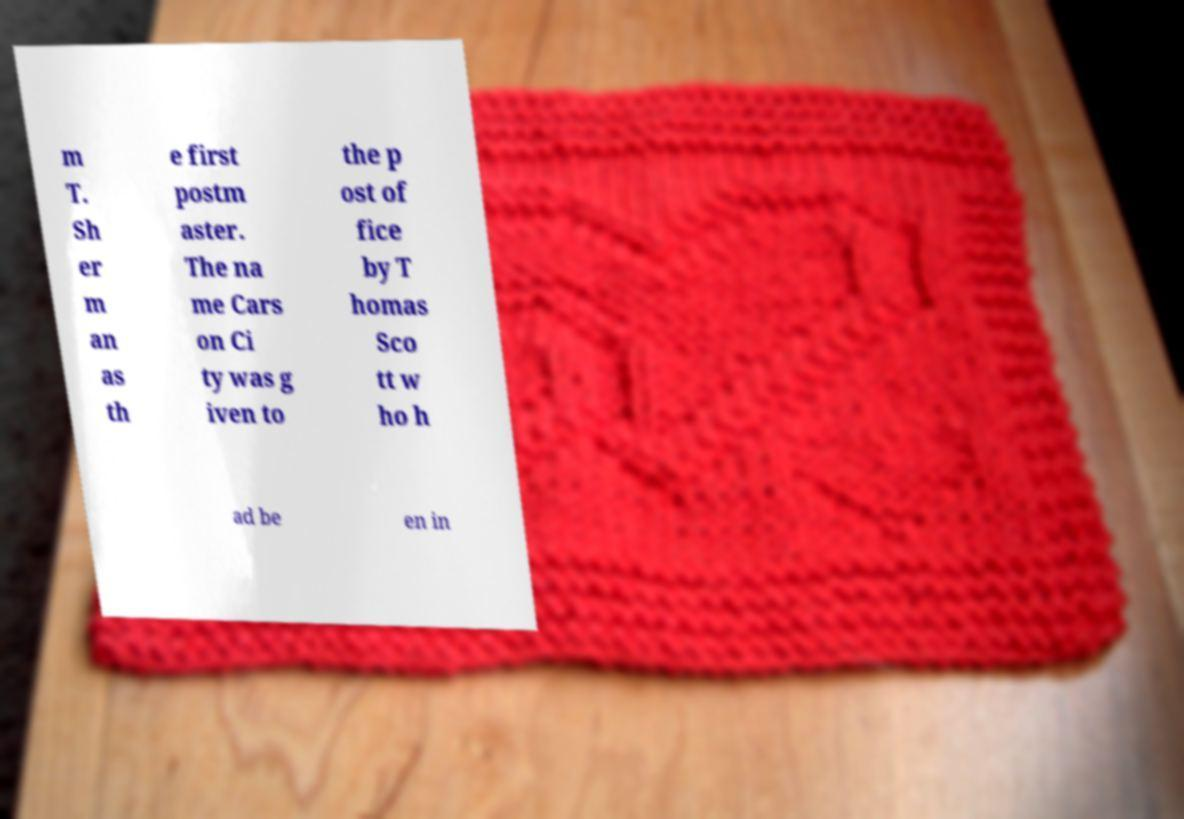Please identify and transcribe the text found in this image. m T. Sh er m an as th e first postm aster. The na me Cars on Ci ty was g iven to the p ost of fice by T homas Sco tt w ho h ad be en in 